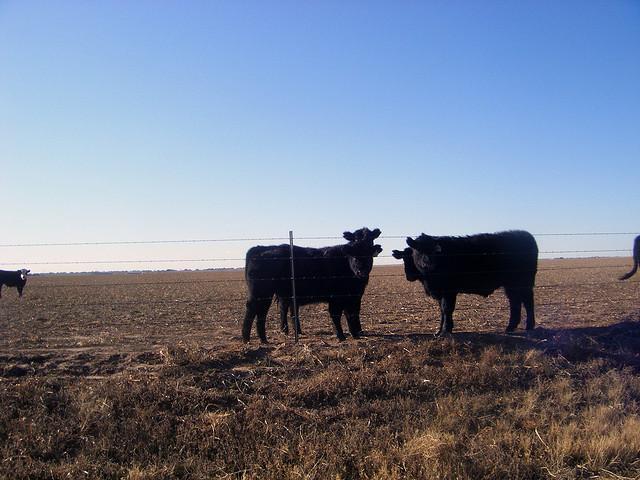How many cows are there?
Give a very brief answer. 2. 